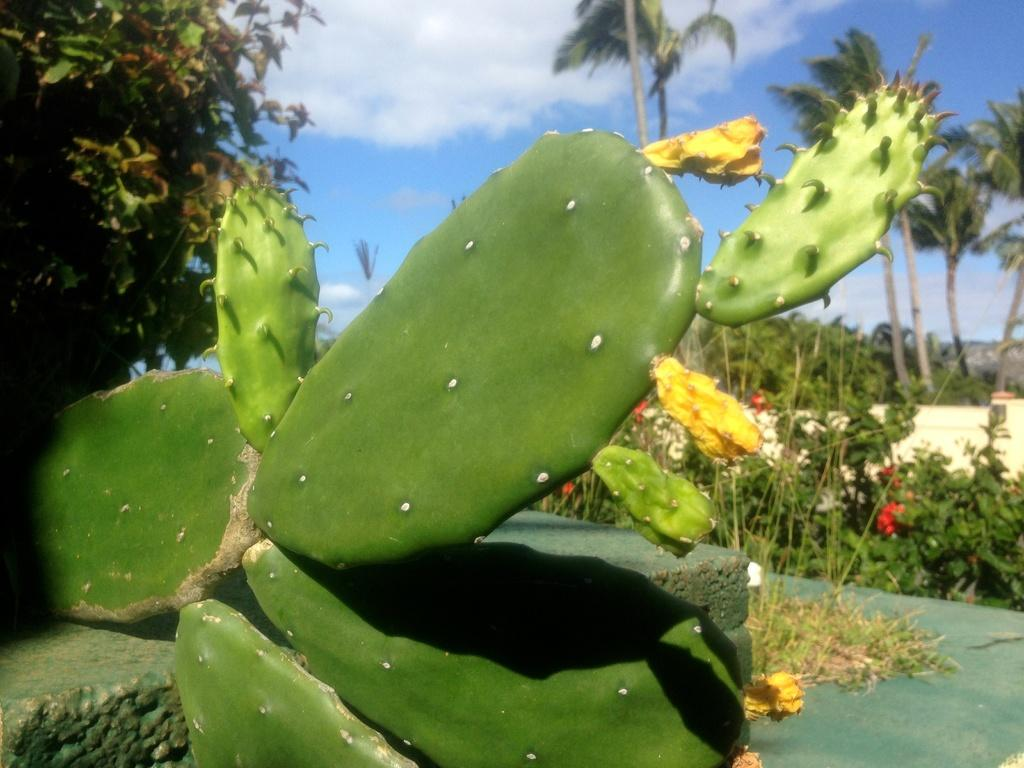What is the main subject of the image? There is an eastern prickly pear plant in the center of the image. Can you describe the surrounding environment in the image? There are other trees and plants in the background of the image. What type of face can be seen on the eastern prickly pear plant in the image? There is no face present on the eastern prickly pear plant in the image. 